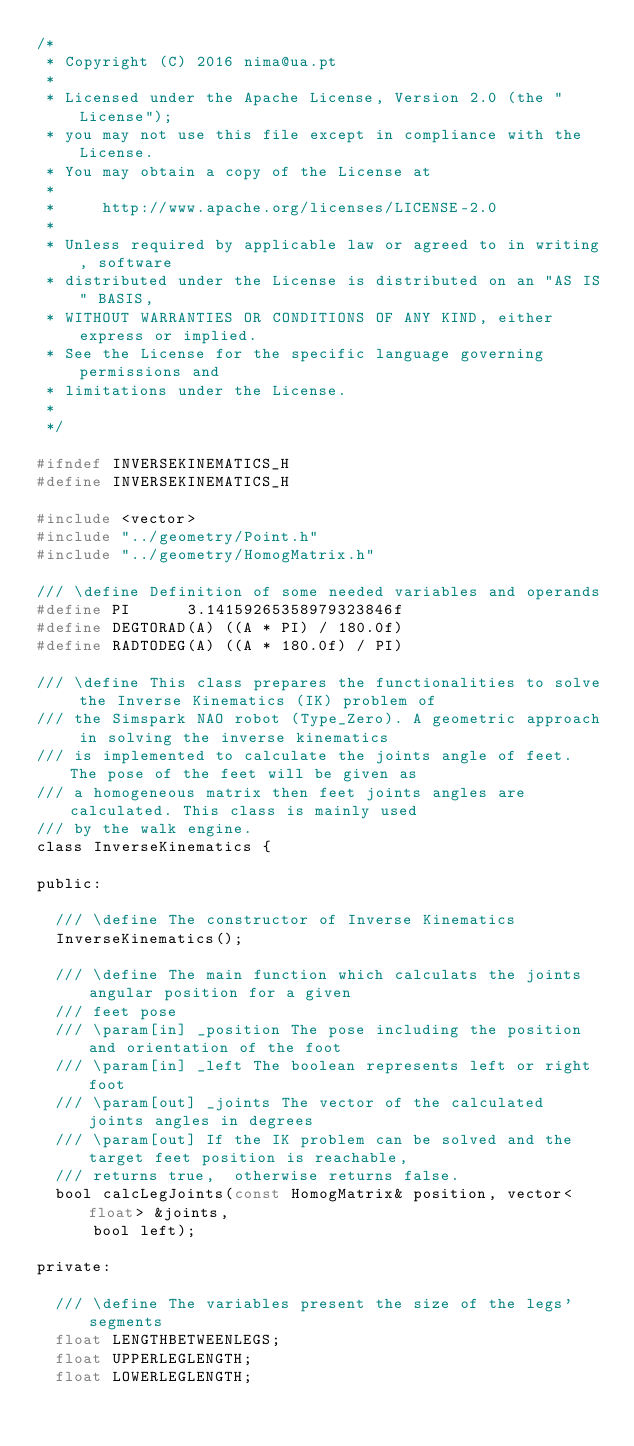<code> <loc_0><loc_0><loc_500><loc_500><_C_>/*
 * Copyright (C) 2016 nima@ua.pt
 *
 * Licensed under the Apache License, Version 2.0 (the "License");
 * you may not use this file except in compliance with the License.
 * You may obtain a copy of the License at
 *
 *     http://www.apache.org/licenses/LICENSE-2.0
 *
 * Unless required by applicable law or agreed to in writing, software
 * distributed under the License is distributed on an "AS IS" BASIS,
 * WITHOUT WARRANTIES OR CONDITIONS OF ANY KIND, either express or implied.
 * See the License for the specific language governing permissions and
 * limitations under the License.
 *
 */

#ifndef INVERSEKINEMATICS_H
#define INVERSEKINEMATICS_H

#include <vector>
#include "../geometry/Point.h"
#include "../geometry/HomogMatrix.h"

/// \define Definition of some needed variables and operands
#define PI		3.14159265358979323846f
#define DEGTORAD(A)	((A * PI) / 180.0f)
#define RADTODEG(A)	((A * 180.0f) / PI)

/// \define This class prepares the functionalities to solve the Inverse Kinematics (IK) problem of
/// the Simspark NAO robot (Type_Zero). A geometric approach in solving the inverse kinematics
/// is implemented to calculate the joints angle of feet. The pose of the feet will be given as
/// a homogeneous matrix then feet joints angles are calculated. This class is mainly used
/// by the walk engine.
class InverseKinematics {

public:

  /// \define The constructor of Inverse Kinematics
  InverseKinematics();

  /// \define The main function which calculats the joints angular position for a given
  /// feet pose
  /// \param[in] _position The pose including the position and orientation of the foot
  /// \param[in] _left The boolean represents left or right foot
  /// \param[out] _joints The vector of the calculated joints angles in degrees
  /// \param[out] If the IK problem can be solved and the target feet position is reachable,
  /// returns true,  otherwise returns false.
  bool calcLegJoints(const HomogMatrix& position, vector<float> &joints,
      bool left);

private:

  /// \define The variables present the size of the legs' segments
  float LENGTHBETWEENLEGS;
  float UPPERLEGLENGTH;
  float LOWERLEGLENGTH;
</code> 